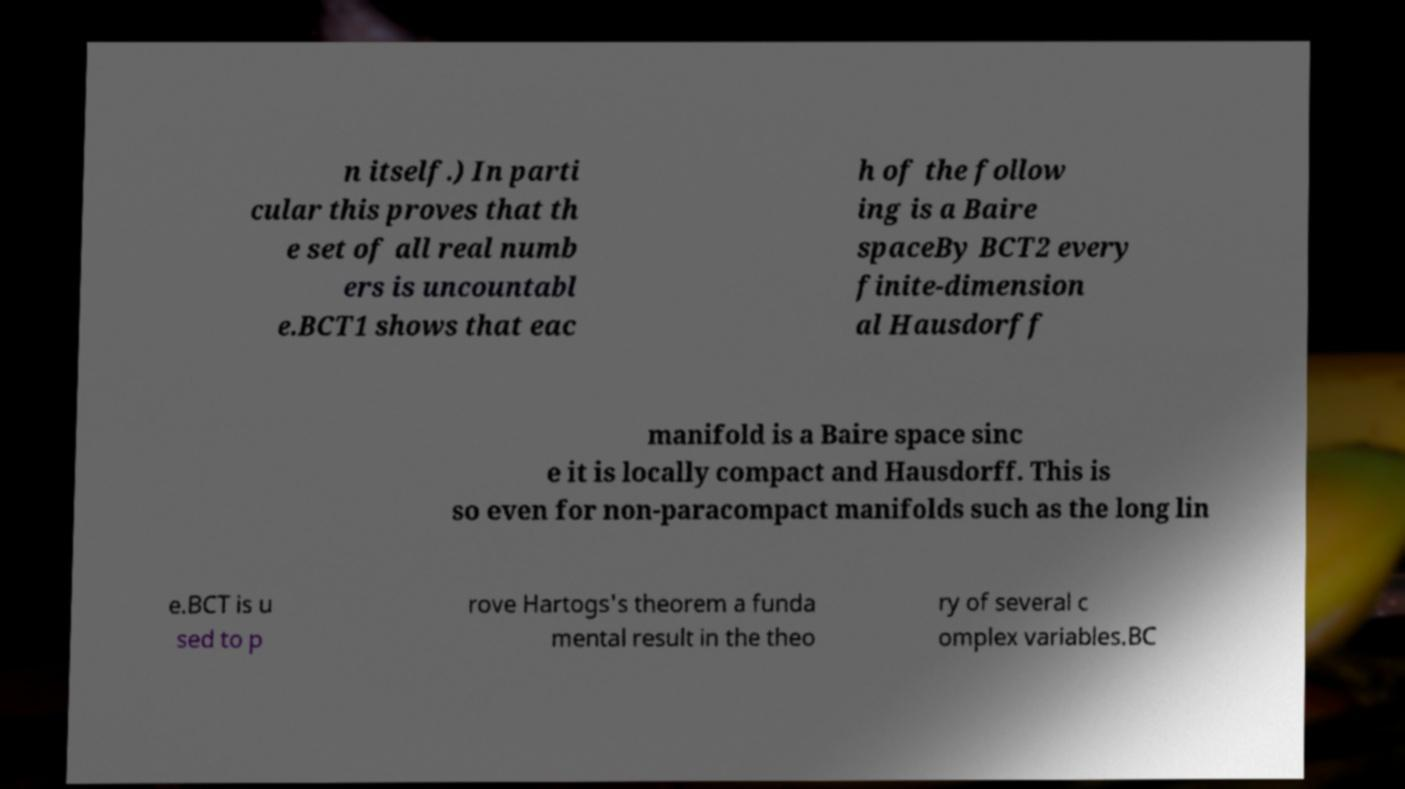For documentation purposes, I need the text within this image transcribed. Could you provide that? n itself.) In parti cular this proves that th e set of all real numb ers is uncountabl e.BCT1 shows that eac h of the follow ing is a Baire spaceBy BCT2 every finite-dimension al Hausdorff manifold is a Baire space sinc e it is locally compact and Hausdorff. This is so even for non-paracompact manifolds such as the long lin e.BCT is u sed to p rove Hartogs's theorem a funda mental result in the theo ry of several c omplex variables.BC 